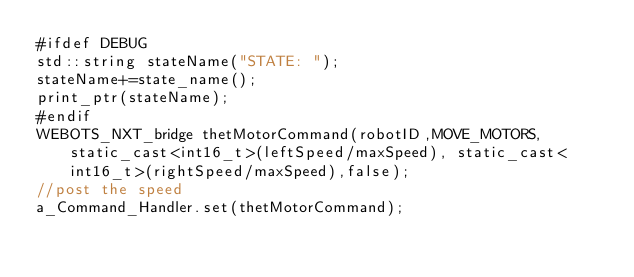<code> <loc_0><loc_0><loc_500><loc_500><_ObjectiveC_>#ifdef DEBUG
std::string stateName("STATE: ");
stateName+=state_name();
print_ptr(stateName);
#endif
WEBOTS_NXT_bridge thetMotorCommand(robotID,MOVE_MOTORS,static_cast<int16_t>(leftSpeed/maxSpeed), static_cast<int16_t>(rightSpeed/maxSpeed),false);
//post the speed
a_Command_Handler.set(thetMotorCommand);
</code> 